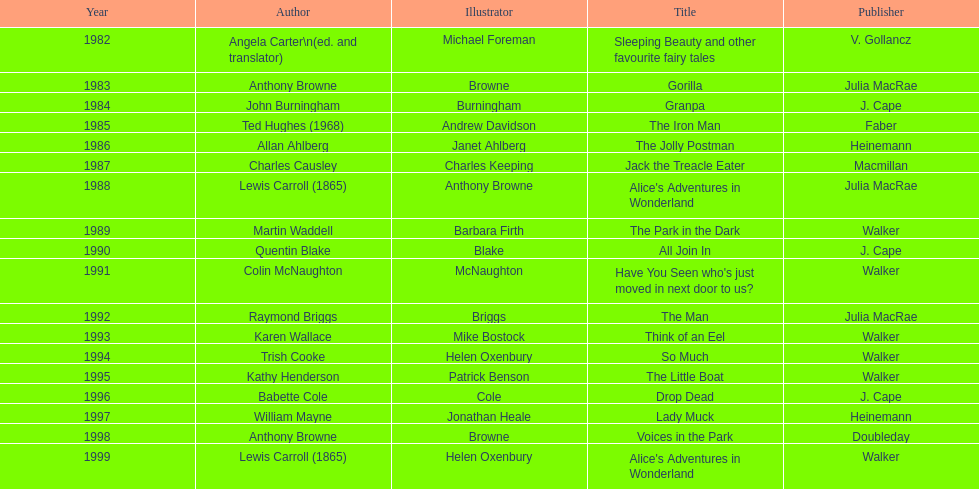How many times has anthony browne won an kurt maschler award for illustration? 3. 